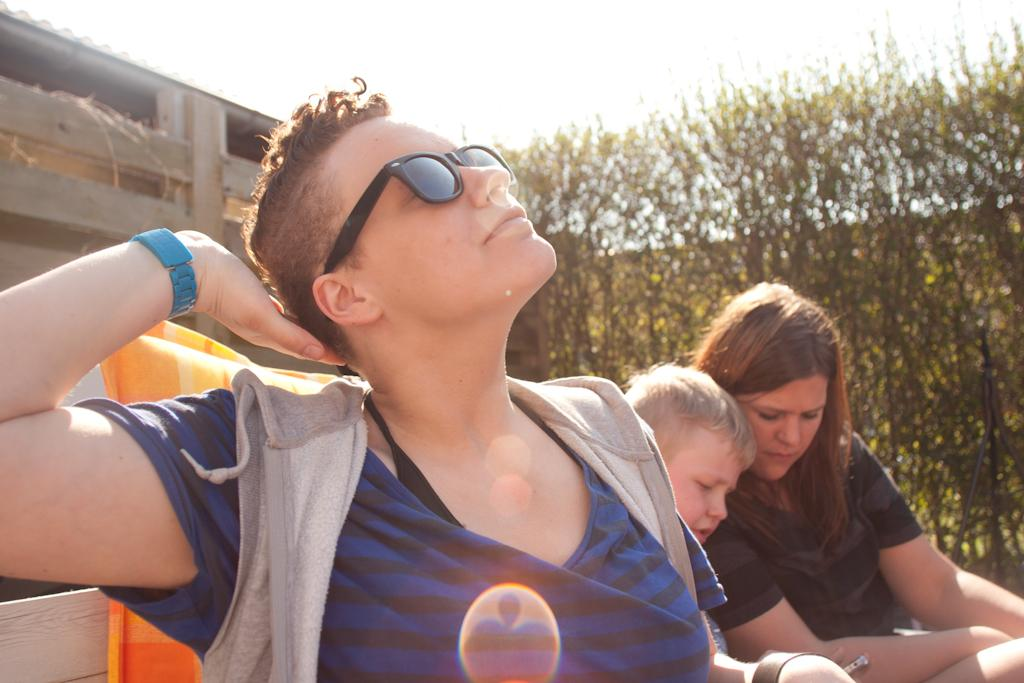What is the person in the image wearing on their face? The person in the image is wearing spectacles. How many other people are in the image besides the person with spectacles? There are two other people in the image. What type of vegetation can be seen in the image? There are plants visible in the image. What type of religious ceremony is taking place in the image? There is no indication of a religious ceremony in the image; it simply features a person wearing spectacles and two other people. Is there any snow visible in the image? There is no snow present in the image. 